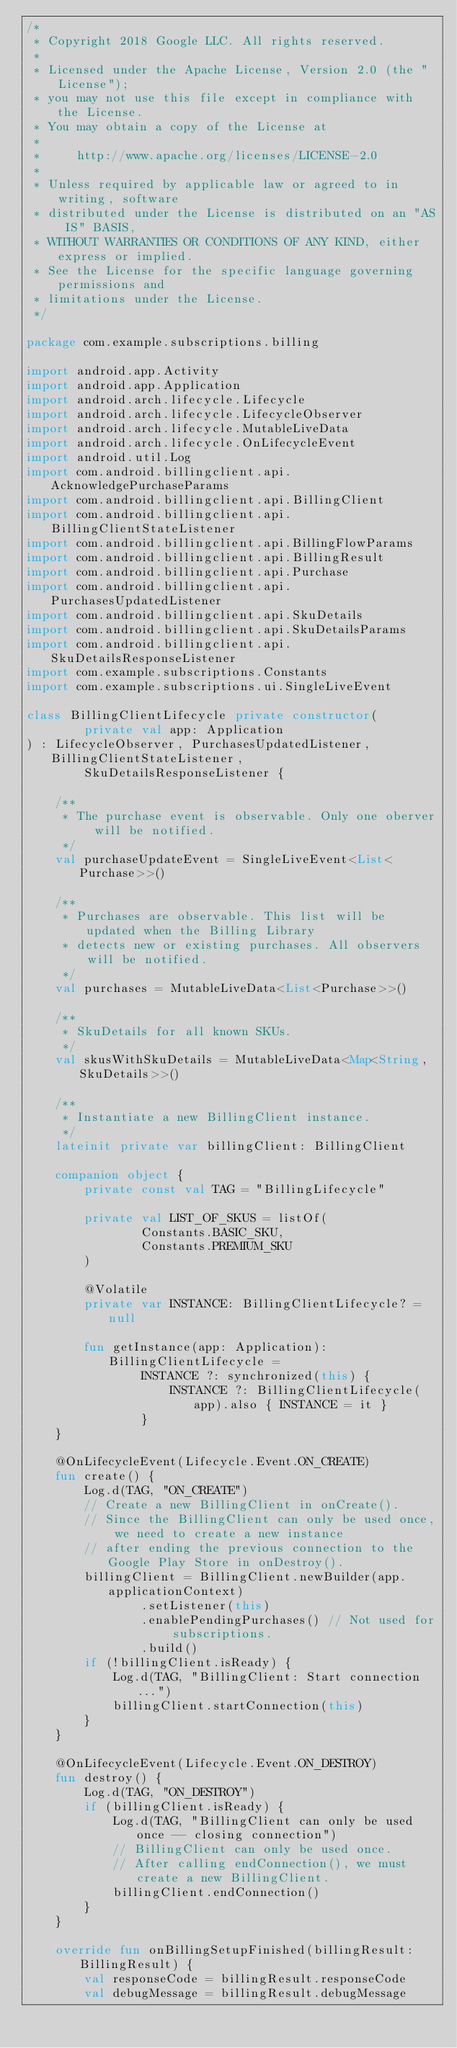Convert code to text. <code><loc_0><loc_0><loc_500><loc_500><_Kotlin_>/*
 * Copyright 2018 Google LLC. All rights reserved.
 *
 * Licensed under the Apache License, Version 2.0 (the "License");
 * you may not use this file except in compliance with the License.
 * You may obtain a copy of the License at
 *
 *     http://www.apache.org/licenses/LICENSE-2.0
 *
 * Unless required by applicable law or agreed to in writing, software
 * distributed under the License is distributed on an "AS IS" BASIS,
 * WITHOUT WARRANTIES OR CONDITIONS OF ANY KIND, either express or implied.
 * See the License for the specific language governing permissions and
 * limitations under the License.
 */

package com.example.subscriptions.billing

import android.app.Activity
import android.app.Application
import android.arch.lifecycle.Lifecycle
import android.arch.lifecycle.LifecycleObserver
import android.arch.lifecycle.MutableLiveData
import android.arch.lifecycle.OnLifecycleEvent
import android.util.Log
import com.android.billingclient.api.AcknowledgePurchaseParams
import com.android.billingclient.api.BillingClient
import com.android.billingclient.api.BillingClientStateListener
import com.android.billingclient.api.BillingFlowParams
import com.android.billingclient.api.BillingResult
import com.android.billingclient.api.Purchase
import com.android.billingclient.api.PurchasesUpdatedListener
import com.android.billingclient.api.SkuDetails
import com.android.billingclient.api.SkuDetailsParams
import com.android.billingclient.api.SkuDetailsResponseListener
import com.example.subscriptions.Constants
import com.example.subscriptions.ui.SingleLiveEvent

class BillingClientLifecycle private constructor(
        private val app: Application
) : LifecycleObserver, PurchasesUpdatedListener, BillingClientStateListener,
        SkuDetailsResponseListener {

    /**
     * The purchase event is observable. Only one oberver will be notified.
     */
    val purchaseUpdateEvent = SingleLiveEvent<List<Purchase>>()

    /**
     * Purchases are observable. This list will be updated when the Billing Library
     * detects new or existing purchases. All observers will be notified.
     */
    val purchases = MutableLiveData<List<Purchase>>()

    /**
     * SkuDetails for all known SKUs.
     */
    val skusWithSkuDetails = MutableLiveData<Map<String, SkuDetails>>()

    /**
     * Instantiate a new BillingClient instance.
     */
    lateinit private var billingClient: BillingClient

    companion object {
        private const val TAG = "BillingLifecycle"

        private val LIST_OF_SKUS = listOf(
                Constants.BASIC_SKU,
                Constants.PREMIUM_SKU
        )

        @Volatile
        private var INSTANCE: BillingClientLifecycle? = null

        fun getInstance(app: Application): BillingClientLifecycle =
                INSTANCE ?: synchronized(this) {
                    INSTANCE ?: BillingClientLifecycle(app).also { INSTANCE = it }
                }
    }

    @OnLifecycleEvent(Lifecycle.Event.ON_CREATE)
    fun create() {
        Log.d(TAG, "ON_CREATE")
        // Create a new BillingClient in onCreate().
        // Since the BillingClient can only be used once, we need to create a new instance
        // after ending the previous connection to the Google Play Store in onDestroy().
        billingClient = BillingClient.newBuilder(app.applicationContext)
                .setListener(this)
                .enablePendingPurchases() // Not used for subscriptions.
                .build()
        if (!billingClient.isReady) {
            Log.d(TAG, "BillingClient: Start connection...")
            billingClient.startConnection(this)
        }
    }

    @OnLifecycleEvent(Lifecycle.Event.ON_DESTROY)
    fun destroy() {
        Log.d(TAG, "ON_DESTROY")
        if (billingClient.isReady) {
            Log.d(TAG, "BillingClient can only be used once -- closing connection")
            // BillingClient can only be used once.
            // After calling endConnection(), we must create a new BillingClient.
            billingClient.endConnection()
        }
    }

    override fun onBillingSetupFinished(billingResult: BillingResult) {
        val responseCode = billingResult.responseCode
        val debugMessage = billingResult.debugMessage</code> 